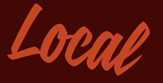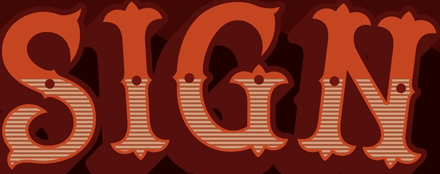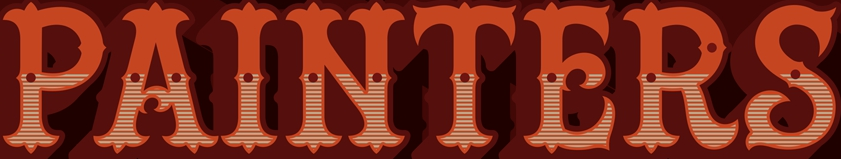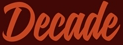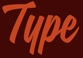What text appears in these images from left to right, separated by a semicolon? Local; SIGN; PAINTERS; Decade; Type 